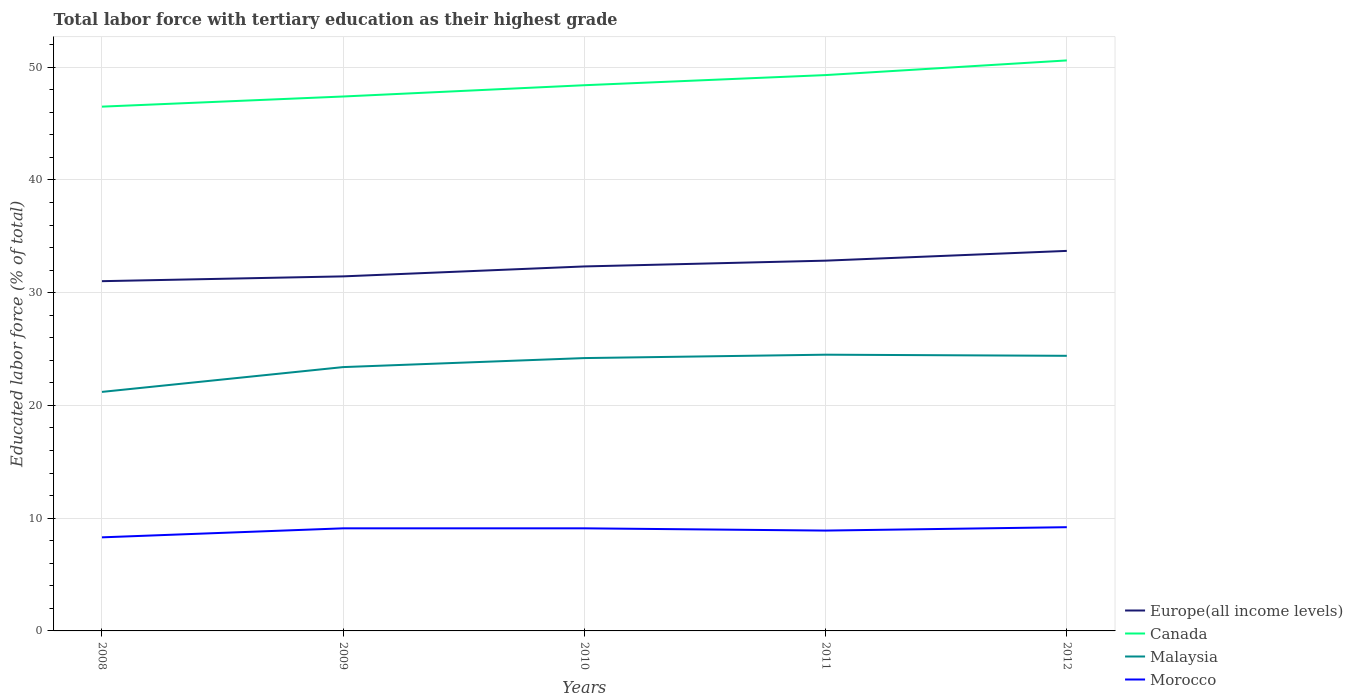Does the line corresponding to Europe(all income levels) intersect with the line corresponding to Canada?
Provide a succinct answer. No. Across all years, what is the maximum percentage of male labor force with tertiary education in Canada?
Ensure brevity in your answer.  46.5. What is the total percentage of male labor force with tertiary education in Europe(all income levels) in the graph?
Make the answer very short. -1.82. What is the difference between the highest and the second highest percentage of male labor force with tertiary education in Europe(all income levels)?
Offer a very short reply. 2.69. Is the percentage of male labor force with tertiary education in Canada strictly greater than the percentage of male labor force with tertiary education in Malaysia over the years?
Give a very brief answer. No. Are the values on the major ticks of Y-axis written in scientific E-notation?
Provide a succinct answer. No. Does the graph contain grids?
Make the answer very short. Yes. How many legend labels are there?
Ensure brevity in your answer.  4. How are the legend labels stacked?
Make the answer very short. Vertical. What is the title of the graph?
Keep it short and to the point. Total labor force with tertiary education as their highest grade. Does "Maldives" appear as one of the legend labels in the graph?
Ensure brevity in your answer.  No. What is the label or title of the Y-axis?
Give a very brief answer. Educated labor force (% of total). What is the Educated labor force (% of total) in Europe(all income levels) in 2008?
Make the answer very short. 31.02. What is the Educated labor force (% of total) of Canada in 2008?
Provide a short and direct response. 46.5. What is the Educated labor force (% of total) of Malaysia in 2008?
Your response must be concise. 21.2. What is the Educated labor force (% of total) of Morocco in 2008?
Your answer should be very brief. 8.3. What is the Educated labor force (% of total) of Europe(all income levels) in 2009?
Offer a very short reply. 31.45. What is the Educated labor force (% of total) in Canada in 2009?
Make the answer very short. 47.4. What is the Educated labor force (% of total) in Malaysia in 2009?
Offer a terse response. 23.4. What is the Educated labor force (% of total) in Morocco in 2009?
Your answer should be compact. 9.1. What is the Educated labor force (% of total) of Europe(all income levels) in 2010?
Your answer should be very brief. 32.33. What is the Educated labor force (% of total) in Canada in 2010?
Keep it short and to the point. 48.4. What is the Educated labor force (% of total) in Malaysia in 2010?
Your answer should be compact. 24.2. What is the Educated labor force (% of total) of Morocco in 2010?
Provide a short and direct response. 9.1. What is the Educated labor force (% of total) of Europe(all income levels) in 2011?
Keep it short and to the point. 32.84. What is the Educated labor force (% of total) of Canada in 2011?
Make the answer very short. 49.3. What is the Educated labor force (% of total) in Malaysia in 2011?
Make the answer very short. 24.5. What is the Educated labor force (% of total) in Morocco in 2011?
Your response must be concise. 8.9. What is the Educated labor force (% of total) of Europe(all income levels) in 2012?
Offer a terse response. 33.71. What is the Educated labor force (% of total) in Canada in 2012?
Your answer should be very brief. 50.6. What is the Educated labor force (% of total) in Malaysia in 2012?
Ensure brevity in your answer.  24.4. What is the Educated labor force (% of total) of Morocco in 2012?
Keep it short and to the point. 9.2. Across all years, what is the maximum Educated labor force (% of total) of Europe(all income levels)?
Your answer should be compact. 33.71. Across all years, what is the maximum Educated labor force (% of total) in Canada?
Your response must be concise. 50.6. Across all years, what is the maximum Educated labor force (% of total) of Malaysia?
Offer a very short reply. 24.5. Across all years, what is the maximum Educated labor force (% of total) in Morocco?
Offer a very short reply. 9.2. Across all years, what is the minimum Educated labor force (% of total) of Europe(all income levels)?
Offer a terse response. 31.02. Across all years, what is the minimum Educated labor force (% of total) in Canada?
Give a very brief answer. 46.5. Across all years, what is the minimum Educated labor force (% of total) of Malaysia?
Provide a short and direct response. 21.2. Across all years, what is the minimum Educated labor force (% of total) of Morocco?
Give a very brief answer. 8.3. What is the total Educated labor force (% of total) in Europe(all income levels) in the graph?
Offer a terse response. 161.34. What is the total Educated labor force (% of total) of Canada in the graph?
Provide a short and direct response. 242.2. What is the total Educated labor force (% of total) in Malaysia in the graph?
Provide a succinct answer. 117.7. What is the total Educated labor force (% of total) in Morocco in the graph?
Offer a very short reply. 44.6. What is the difference between the Educated labor force (% of total) of Europe(all income levels) in 2008 and that in 2009?
Your answer should be compact. -0.43. What is the difference between the Educated labor force (% of total) in Canada in 2008 and that in 2009?
Your answer should be compact. -0.9. What is the difference between the Educated labor force (% of total) in Malaysia in 2008 and that in 2009?
Your answer should be very brief. -2.2. What is the difference between the Educated labor force (% of total) in Europe(all income levels) in 2008 and that in 2010?
Your answer should be compact. -1.31. What is the difference between the Educated labor force (% of total) of Malaysia in 2008 and that in 2010?
Your answer should be compact. -3. What is the difference between the Educated labor force (% of total) of Europe(all income levels) in 2008 and that in 2011?
Offer a very short reply. -1.82. What is the difference between the Educated labor force (% of total) in Canada in 2008 and that in 2011?
Offer a terse response. -2.8. What is the difference between the Educated labor force (% of total) in Malaysia in 2008 and that in 2011?
Keep it short and to the point. -3.3. What is the difference between the Educated labor force (% of total) in Europe(all income levels) in 2008 and that in 2012?
Keep it short and to the point. -2.69. What is the difference between the Educated labor force (% of total) in Canada in 2008 and that in 2012?
Your response must be concise. -4.1. What is the difference between the Educated labor force (% of total) of Malaysia in 2008 and that in 2012?
Keep it short and to the point. -3.2. What is the difference between the Educated labor force (% of total) in Europe(all income levels) in 2009 and that in 2010?
Offer a very short reply. -0.88. What is the difference between the Educated labor force (% of total) of Canada in 2009 and that in 2010?
Give a very brief answer. -1. What is the difference between the Educated labor force (% of total) of Malaysia in 2009 and that in 2010?
Offer a terse response. -0.8. What is the difference between the Educated labor force (% of total) of Morocco in 2009 and that in 2010?
Offer a terse response. 0. What is the difference between the Educated labor force (% of total) in Europe(all income levels) in 2009 and that in 2011?
Make the answer very short. -1.39. What is the difference between the Educated labor force (% of total) of Canada in 2009 and that in 2011?
Your answer should be very brief. -1.9. What is the difference between the Educated labor force (% of total) in Malaysia in 2009 and that in 2011?
Your response must be concise. -1.1. What is the difference between the Educated labor force (% of total) of Morocco in 2009 and that in 2011?
Ensure brevity in your answer.  0.2. What is the difference between the Educated labor force (% of total) in Europe(all income levels) in 2009 and that in 2012?
Your answer should be very brief. -2.26. What is the difference between the Educated labor force (% of total) of Malaysia in 2009 and that in 2012?
Ensure brevity in your answer.  -1. What is the difference between the Educated labor force (% of total) in Morocco in 2009 and that in 2012?
Offer a very short reply. -0.1. What is the difference between the Educated labor force (% of total) in Europe(all income levels) in 2010 and that in 2011?
Provide a succinct answer. -0.51. What is the difference between the Educated labor force (% of total) in Canada in 2010 and that in 2011?
Offer a very short reply. -0.9. What is the difference between the Educated labor force (% of total) of Europe(all income levels) in 2010 and that in 2012?
Your answer should be very brief. -1.38. What is the difference between the Educated labor force (% of total) in Malaysia in 2010 and that in 2012?
Offer a very short reply. -0.2. What is the difference between the Educated labor force (% of total) of Europe(all income levels) in 2011 and that in 2012?
Ensure brevity in your answer.  -0.87. What is the difference between the Educated labor force (% of total) in Malaysia in 2011 and that in 2012?
Your answer should be very brief. 0.1. What is the difference between the Educated labor force (% of total) of Europe(all income levels) in 2008 and the Educated labor force (% of total) of Canada in 2009?
Provide a short and direct response. -16.38. What is the difference between the Educated labor force (% of total) in Europe(all income levels) in 2008 and the Educated labor force (% of total) in Malaysia in 2009?
Offer a terse response. 7.62. What is the difference between the Educated labor force (% of total) of Europe(all income levels) in 2008 and the Educated labor force (% of total) of Morocco in 2009?
Offer a very short reply. 21.92. What is the difference between the Educated labor force (% of total) in Canada in 2008 and the Educated labor force (% of total) in Malaysia in 2009?
Your answer should be very brief. 23.1. What is the difference between the Educated labor force (% of total) of Canada in 2008 and the Educated labor force (% of total) of Morocco in 2009?
Make the answer very short. 37.4. What is the difference between the Educated labor force (% of total) in Europe(all income levels) in 2008 and the Educated labor force (% of total) in Canada in 2010?
Offer a terse response. -17.38. What is the difference between the Educated labor force (% of total) of Europe(all income levels) in 2008 and the Educated labor force (% of total) of Malaysia in 2010?
Give a very brief answer. 6.82. What is the difference between the Educated labor force (% of total) in Europe(all income levels) in 2008 and the Educated labor force (% of total) in Morocco in 2010?
Your response must be concise. 21.92. What is the difference between the Educated labor force (% of total) in Canada in 2008 and the Educated labor force (% of total) in Malaysia in 2010?
Ensure brevity in your answer.  22.3. What is the difference between the Educated labor force (% of total) of Canada in 2008 and the Educated labor force (% of total) of Morocco in 2010?
Your answer should be compact. 37.4. What is the difference between the Educated labor force (% of total) in Europe(all income levels) in 2008 and the Educated labor force (% of total) in Canada in 2011?
Offer a terse response. -18.28. What is the difference between the Educated labor force (% of total) of Europe(all income levels) in 2008 and the Educated labor force (% of total) of Malaysia in 2011?
Your answer should be compact. 6.52. What is the difference between the Educated labor force (% of total) of Europe(all income levels) in 2008 and the Educated labor force (% of total) of Morocco in 2011?
Offer a terse response. 22.12. What is the difference between the Educated labor force (% of total) in Canada in 2008 and the Educated labor force (% of total) in Morocco in 2011?
Offer a very short reply. 37.6. What is the difference between the Educated labor force (% of total) of Malaysia in 2008 and the Educated labor force (% of total) of Morocco in 2011?
Your response must be concise. 12.3. What is the difference between the Educated labor force (% of total) in Europe(all income levels) in 2008 and the Educated labor force (% of total) in Canada in 2012?
Provide a short and direct response. -19.58. What is the difference between the Educated labor force (% of total) in Europe(all income levels) in 2008 and the Educated labor force (% of total) in Malaysia in 2012?
Provide a short and direct response. 6.62. What is the difference between the Educated labor force (% of total) in Europe(all income levels) in 2008 and the Educated labor force (% of total) in Morocco in 2012?
Keep it short and to the point. 21.82. What is the difference between the Educated labor force (% of total) of Canada in 2008 and the Educated labor force (% of total) of Malaysia in 2012?
Your answer should be compact. 22.1. What is the difference between the Educated labor force (% of total) of Canada in 2008 and the Educated labor force (% of total) of Morocco in 2012?
Offer a terse response. 37.3. What is the difference between the Educated labor force (% of total) in Malaysia in 2008 and the Educated labor force (% of total) in Morocco in 2012?
Your response must be concise. 12. What is the difference between the Educated labor force (% of total) of Europe(all income levels) in 2009 and the Educated labor force (% of total) of Canada in 2010?
Your answer should be compact. -16.95. What is the difference between the Educated labor force (% of total) in Europe(all income levels) in 2009 and the Educated labor force (% of total) in Malaysia in 2010?
Your answer should be compact. 7.25. What is the difference between the Educated labor force (% of total) of Europe(all income levels) in 2009 and the Educated labor force (% of total) of Morocco in 2010?
Offer a terse response. 22.35. What is the difference between the Educated labor force (% of total) in Canada in 2009 and the Educated labor force (% of total) in Malaysia in 2010?
Give a very brief answer. 23.2. What is the difference between the Educated labor force (% of total) in Canada in 2009 and the Educated labor force (% of total) in Morocco in 2010?
Provide a succinct answer. 38.3. What is the difference between the Educated labor force (% of total) of Europe(all income levels) in 2009 and the Educated labor force (% of total) of Canada in 2011?
Ensure brevity in your answer.  -17.85. What is the difference between the Educated labor force (% of total) in Europe(all income levels) in 2009 and the Educated labor force (% of total) in Malaysia in 2011?
Offer a terse response. 6.95. What is the difference between the Educated labor force (% of total) of Europe(all income levels) in 2009 and the Educated labor force (% of total) of Morocco in 2011?
Offer a terse response. 22.55. What is the difference between the Educated labor force (% of total) in Canada in 2009 and the Educated labor force (% of total) in Malaysia in 2011?
Keep it short and to the point. 22.9. What is the difference between the Educated labor force (% of total) in Canada in 2009 and the Educated labor force (% of total) in Morocco in 2011?
Your answer should be very brief. 38.5. What is the difference between the Educated labor force (% of total) of Europe(all income levels) in 2009 and the Educated labor force (% of total) of Canada in 2012?
Offer a very short reply. -19.15. What is the difference between the Educated labor force (% of total) of Europe(all income levels) in 2009 and the Educated labor force (% of total) of Malaysia in 2012?
Provide a succinct answer. 7.05. What is the difference between the Educated labor force (% of total) in Europe(all income levels) in 2009 and the Educated labor force (% of total) in Morocco in 2012?
Make the answer very short. 22.25. What is the difference between the Educated labor force (% of total) of Canada in 2009 and the Educated labor force (% of total) of Morocco in 2012?
Provide a short and direct response. 38.2. What is the difference between the Educated labor force (% of total) of Malaysia in 2009 and the Educated labor force (% of total) of Morocco in 2012?
Keep it short and to the point. 14.2. What is the difference between the Educated labor force (% of total) in Europe(all income levels) in 2010 and the Educated labor force (% of total) in Canada in 2011?
Your answer should be very brief. -16.97. What is the difference between the Educated labor force (% of total) in Europe(all income levels) in 2010 and the Educated labor force (% of total) in Malaysia in 2011?
Provide a short and direct response. 7.83. What is the difference between the Educated labor force (% of total) of Europe(all income levels) in 2010 and the Educated labor force (% of total) of Morocco in 2011?
Your answer should be very brief. 23.43. What is the difference between the Educated labor force (% of total) in Canada in 2010 and the Educated labor force (% of total) in Malaysia in 2011?
Your response must be concise. 23.9. What is the difference between the Educated labor force (% of total) in Canada in 2010 and the Educated labor force (% of total) in Morocco in 2011?
Offer a very short reply. 39.5. What is the difference between the Educated labor force (% of total) of Malaysia in 2010 and the Educated labor force (% of total) of Morocco in 2011?
Provide a short and direct response. 15.3. What is the difference between the Educated labor force (% of total) in Europe(all income levels) in 2010 and the Educated labor force (% of total) in Canada in 2012?
Make the answer very short. -18.27. What is the difference between the Educated labor force (% of total) in Europe(all income levels) in 2010 and the Educated labor force (% of total) in Malaysia in 2012?
Provide a short and direct response. 7.93. What is the difference between the Educated labor force (% of total) in Europe(all income levels) in 2010 and the Educated labor force (% of total) in Morocco in 2012?
Provide a short and direct response. 23.13. What is the difference between the Educated labor force (% of total) in Canada in 2010 and the Educated labor force (% of total) in Morocco in 2012?
Provide a short and direct response. 39.2. What is the difference between the Educated labor force (% of total) of Europe(all income levels) in 2011 and the Educated labor force (% of total) of Canada in 2012?
Ensure brevity in your answer.  -17.76. What is the difference between the Educated labor force (% of total) in Europe(all income levels) in 2011 and the Educated labor force (% of total) in Malaysia in 2012?
Ensure brevity in your answer.  8.44. What is the difference between the Educated labor force (% of total) of Europe(all income levels) in 2011 and the Educated labor force (% of total) of Morocco in 2012?
Give a very brief answer. 23.64. What is the difference between the Educated labor force (% of total) in Canada in 2011 and the Educated labor force (% of total) in Malaysia in 2012?
Offer a terse response. 24.9. What is the difference between the Educated labor force (% of total) of Canada in 2011 and the Educated labor force (% of total) of Morocco in 2012?
Provide a succinct answer. 40.1. What is the difference between the Educated labor force (% of total) in Malaysia in 2011 and the Educated labor force (% of total) in Morocco in 2012?
Keep it short and to the point. 15.3. What is the average Educated labor force (% of total) in Europe(all income levels) per year?
Your answer should be compact. 32.27. What is the average Educated labor force (% of total) of Canada per year?
Ensure brevity in your answer.  48.44. What is the average Educated labor force (% of total) of Malaysia per year?
Ensure brevity in your answer.  23.54. What is the average Educated labor force (% of total) in Morocco per year?
Offer a very short reply. 8.92. In the year 2008, what is the difference between the Educated labor force (% of total) in Europe(all income levels) and Educated labor force (% of total) in Canada?
Offer a terse response. -15.48. In the year 2008, what is the difference between the Educated labor force (% of total) in Europe(all income levels) and Educated labor force (% of total) in Malaysia?
Your response must be concise. 9.82. In the year 2008, what is the difference between the Educated labor force (% of total) in Europe(all income levels) and Educated labor force (% of total) in Morocco?
Your response must be concise. 22.72. In the year 2008, what is the difference between the Educated labor force (% of total) of Canada and Educated labor force (% of total) of Malaysia?
Offer a terse response. 25.3. In the year 2008, what is the difference between the Educated labor force (% of total) of Canada and Educated labor force (% of total) of Morocco?
Your answer should be compact. 38.2. In the year 2009, what is the difference between the Educated labor force (% of total) of Europe(all income levels) and Educated labor force (% of total) of Canada?
Offer a very short reply. -15.95. In the year 2009, what is the difference between the Educated labor force (% of total) in Europe(all income levels) and Educated labor force (% of total) in Malaysia?
Your answer should be very brief. 8.05. In the year 2009, what is the difference between the Educated labor force (% of total) in Europe(all income levels) and Educated labor force (% of total) in Morocco?
Ensure brevity in your answer.  22.35. In the year 2009, what is the difference between the Educated labor force (% of total) in Canada and Educated labor force (% of total) in Morocco?
Provide a succinct answer. 38.3. In the year 2009, what is the difference between the Educated labor force (% of total) in Malaysia and Educated labor force (% of total) in Morocco?
Your answer should be very brief. 14.3. In the year 2010, what is the difference between the Educated labor force (% of total) of Europe(all income levels) and Educated labor force (% of total) of Canada?
Your answer should be compact. -16.07. In the year 2010, what is the difference between the Educated labor force (% of total) of Europe(all income levels) and Educated labor force (% of total) of Malaysia?
Make the answer very short. 8.13. In the year 2010, what is the difference between the Educated labor force (% of total) in Europe(all income levels) and Educated labor force (% of total) in Morocco?
Give a very brief answer. 23.23. In the year 2010, what is the difference between the Educated labor force (% of total) in Canada and Educated labor force (% of total) in Malaysia?
Your answer should be compact. 24.2. In the year 2010, what is the difference between the Educated labor force (% of total) in Canada and Educated labor force (% of total) in Morocco?
Your answer should be very brief. 39.3. In the year 2011, what is the difference between the Educated labor force (% of total) of Europe(all income levels) and Educated labor force (% of total) of Canada?
Ensure brevity in your answer.  -16.46. In the year 2011, what is the difference between the Educated labor force (% of total) of Europe(all income levels) and Educated labor force (% of total) of Malaysia?
Make the answer very short. 8.34. In the year 2011, what is the difference between the Educated labor force (% of total) in Europe(all income levels) and Educated labor force (% of total) in Morocco?
Offer a very short reply. 23.94. In the year 2011, what is the difference between the Educated labor force (% of total) in Canada and Educated labor force (% of total) in Malaysia?
Ensure brevity in your answer.  24.8. In the year 2011, what is the difference between the Educated labor force (% of total) in Canada and Educated labor force (% of total) in Morocco?
Give a very brief answer. 40.4. In the year 2011, what is the difference between the Educated labor force (% of total) in Malaysia and Educated labor force (% of total) in Morocco?
Provide a short and direct response. 15.6. In the year 2012, what is the difference between the Educated labor force (% of total) of Europe(all income levels) and Educated labor force (% of total) of Canada?
Offer a terse response. -16.89. In the year 2012, what is the difference between the Educated labor force (% of total) of Europe(all income levels) and Educated labor force (% of total) of Malaysia?
Provide a short and direct response. 9.31. In the year 2012, what is the difference between the Educated labor force (% of total) in Europe(all income levels) and Educated labor force (% of total) in Morocco?
Keep it short and to the point. 24.51. In the year 2012, what is the difference between the Educated labor force (% of total) of Canada and Educated labor force (% of total) of Malaysia?
Ensure brevity in your answer.  26.2. In the year 2012, what is the difference between the Educated labor force (% of total) in Canada and Educated labor force (% of total) in Morocco?
Your response must be concise. 41.4. In the year 2012, what is the difference between the Educated labor force (% of total) in Malaysia and Educated labor force (% of total) in Morocco?
Your response must be concise. 15.2. What is the ratio of the Educated labor force (% of total) of Europe(all income levels) in 2008 to that in 2009?
Keep it short and to the point. 0.99. What is the ratio of the Educated labor force (% of total) in Canada in 2008 to that in 2009?
Offer a very short reply. 0.98. What is the ratio of the Educated labor force (% of total) in Malaysia in 2008 to that in 2009?
Offer a terse response. 0.91. What is the ratio of the Educated labor force (% of total) of Morocco in 2008 to that in 2009?
Offer a very short reply. 0.91. What is the ratio of the Educated labor force (% of total) of Europe(all income levels) in 2008 to that in 2010?
Give a very brief answer. 0.96. What is the ratio of the Educated labor force (% of total) of Canada in 2008 to that in 2010?
Your answer should be very brief. 0.96. What is the ratio of the Educated labor force (% of total) of Malaysia in 2008 to that in 2010?
Your response must be concise. 0.88. What is the ratio of the Educated labor force (% of total) in Morocco in 2008 to that in 2010?
Offer a very short reply. 0.91. What is the ratio of the Educated labor force (% of total) in Europe(all income levels) in 2008 to that in 2011?
Offer a very short reply. 0.94. What is the ratio of the Educated labor force (% of total) of Canada in 2008 to that in 2011?
Your response must be concise. 0.94. What is the ratio of the Educated labor force (% of total) of Malaysia in 2008 to that in 2011?
Ensure brevity in your answer.  0.87. What is the ratio of the Educated labor force (% of total) in Morocco in 2008 to that in 2011?
Your answer should be very brief. 0.93. What is the ratio of the Educated labor force (% of total) of Europe(all income levels) in 2008 to that in 2012?
Ensure brevity in your answer.  0.92. What is the ratio of the Educated labor force (% of total) in Canada in 2008 to that in 2012?
Offer a terse response. 0.92. What is the ratio of the Educated labor force (% of total) in Malaysia in 2008 to that in 2012?
Offer a very short reply. 0.87. What is the ratio of the Educated labor force (% of total) of Morocco in 2008 to that in 2012?
Your answer should be very brief. 0.9. What is the ratio of the Educated labor force (% of total) of Europe(all income levels) in 2009 to that in 2010?
Offer a terse response. 0.97. What is the ratio of the Educated labor force (% of total) of Canada in 2009 to that in 2010?
Keep it short and to the point. 0.98. What is the ratio of the Educated labor force (% of total) of Malaysia in 2009 to that in 2010?
Ensure brevity in your answer.  0.97. What is the ratio of the Educated labor force (% of total) of Morocco in 2009 to that in 2010?
Your answer should be compact. 1. What is the ratio of the Educated labor force (% of total) of Europe(all income levels) in 2009 to that in 2011?
Your answer should be very brief. 0.96. What is the ratio of the Educated labor force (% of total) in Canada in 2009 to that in 2011?
Your response must be concise. 0.96. What is the ratio of the Educated labor force (% of total) of Malaysia in 2009 to that in 2011?
Your answer should be compact. 0.96. What is the ratio of the Educated labor force (% of total) in Morocco in 2009 to that in 2011?
Your answer should be compact. 1.02. What is the ratio of the Educated labor force (% of total) of Europe(all income levels) in 2009 to that in 2012?
Keep it short and to the point. 0.93. What is the ratio of the Educated labor force (% of total) of Canada in 2009 to that in 2012?
Your response must be concise. 0.94. What is the ratio of the Educated labor force (% of total) of Europe(all income levels) in 2010 to that in 2011?
Keep it short and to the point. 0.98. What is the ratio of the Educated labor force (% of total) in Canada in 2010 to that in 2011?
Provide a succinct answer. 0.98. What is the ratio of the Educated labor force (% of total) in Morocco in 2010 to that in 2011?
Provide a succinct answer. 1.02. What is the ratio of the Educated labor force (% of total) of Europe(all income levels) in 2010 to that in 2012?
Make the answer very short. 0.96. What is the ratio of the Educated labor force (% of total) in Canada in 2010 to that in 2012?
Offer a terse response. 0.96. What is the ratio of the Educated labor force (% of total) in Morocco in 2010 to that in 2012?
Provide a succinct answer. 0.99. What is the ratio of the Educated labor force (% of total) in Europe(all income levels) in 2011 to that in 2012?
Make the answer very short. 0.97. What is the ratio of the Educated labor force (% of total) in Canada in 2011 to that in 2012?
Offer a very short reply. 0.97. What is the ratio of the Educated labor force (% of total) of Malaysia in 2011 to that in 2012?
Ensure brevity in your answer.  1. What is the ratio of the Educated labor force (% of total) of Morocco in 2011 to that in 2012?
Provide a succinct answer. 0.97. What is the difference between the highest and the second highest Educated labor force (% of total) in Europe(all income levels)?
Your answer should be very brief. 0.87. What is the difference between the highest and the lowest Educated labor force (% of total) of Europe(all income levels)?
Offer a terse response. 2.69. 